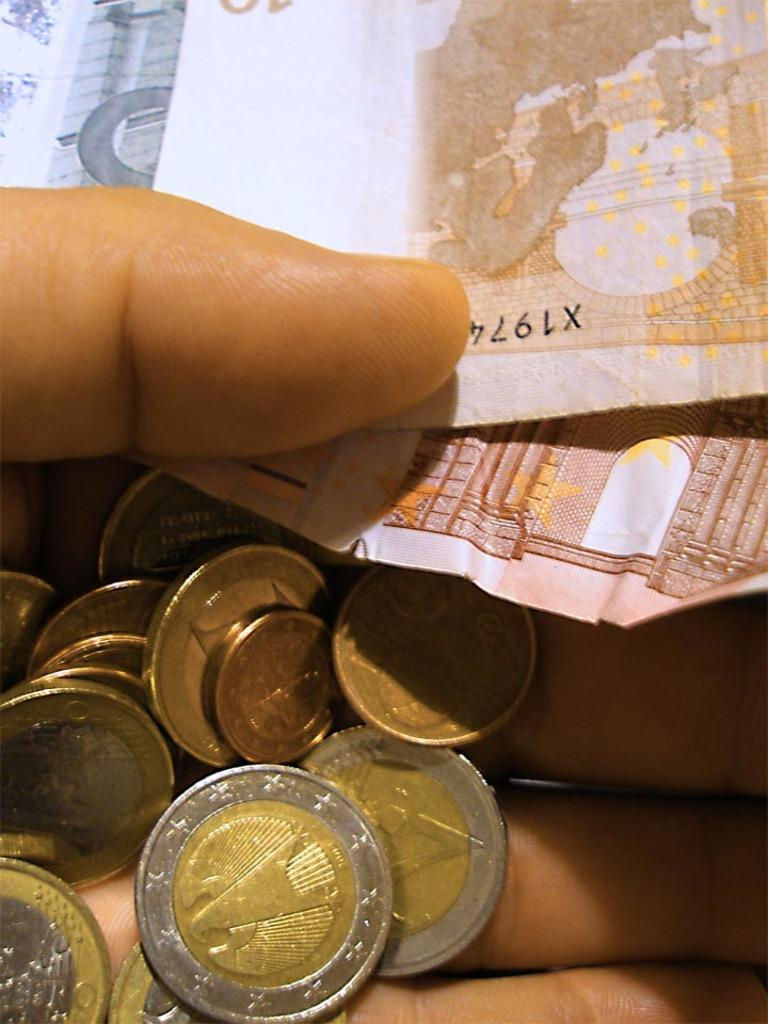Provide a one-sentence caption for the provided image. a hand holding a bunch of coins and some paper money, one has X1974 on it. 